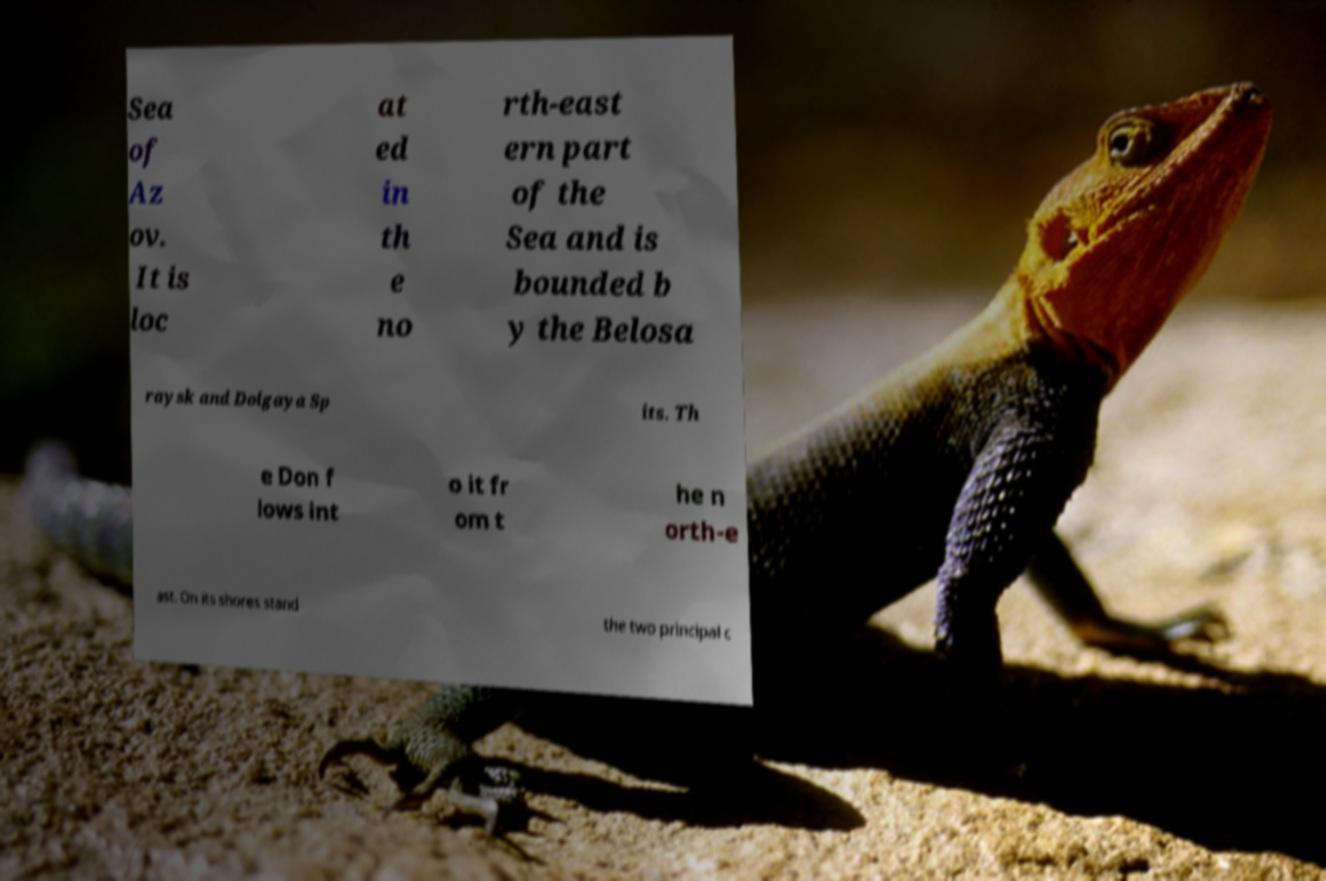Could you extract and type out the text from this image? Sea of Az ov. It is loc at ed in th e no rth-east ern part of the Sea and is bounded b y the Belosa raysk and Dolgaya Sp its. Th e Don f lows int o it fr om t he n orth-e ast. On its shores stand the two principal c 